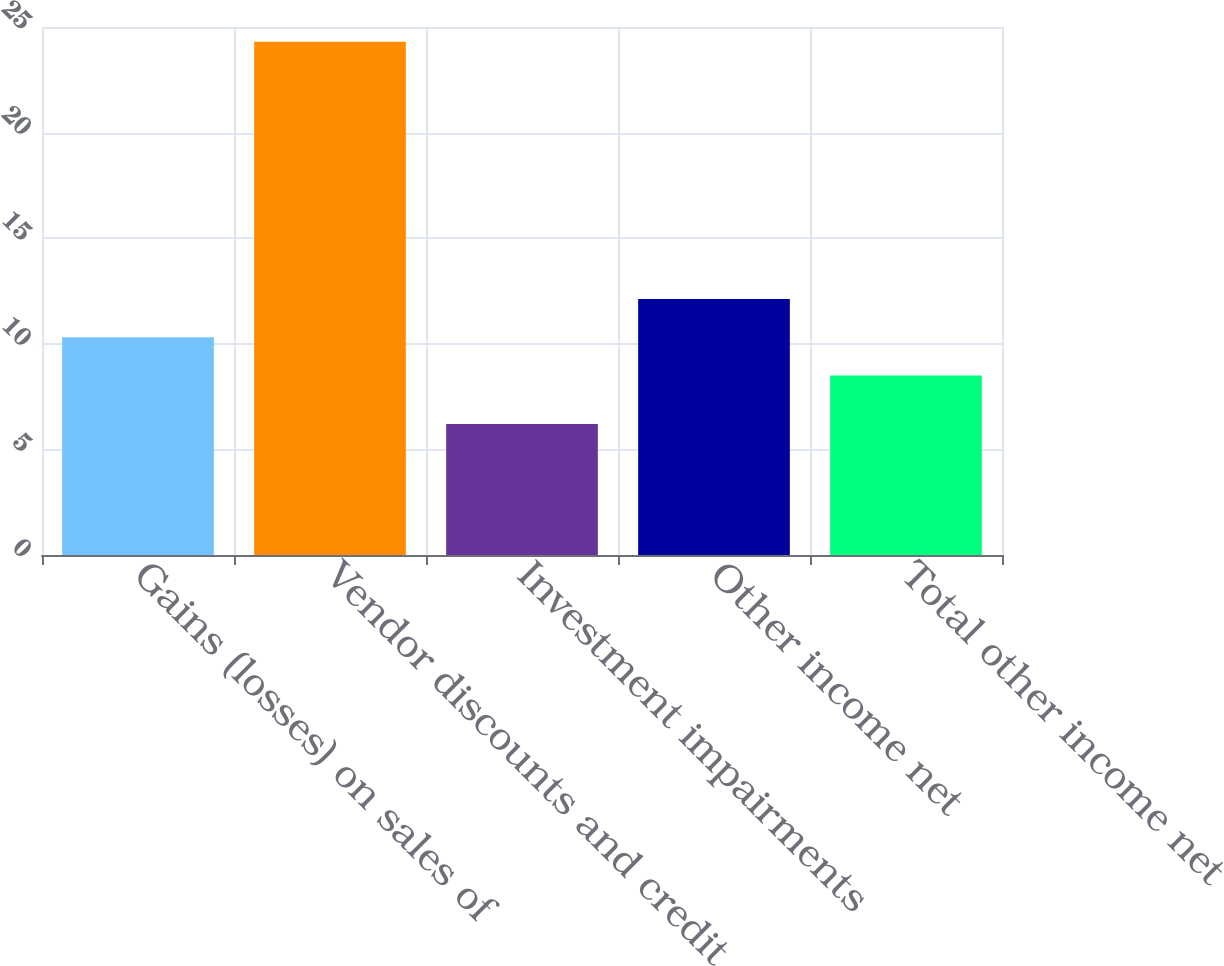<chart> <loc_0><loc_0><loc_500><loc_500><bar_chart><fcel>Gains (losses) on sales of<fcel>Vendor discounts and credit<fcel>Investment impairments<fcel>Other income net<fcel>Total other income net<nl><fcel>10.31<fcel>24.3<fcel>6.2<fcel>12.12<fcel>8.5<nl></chart> 